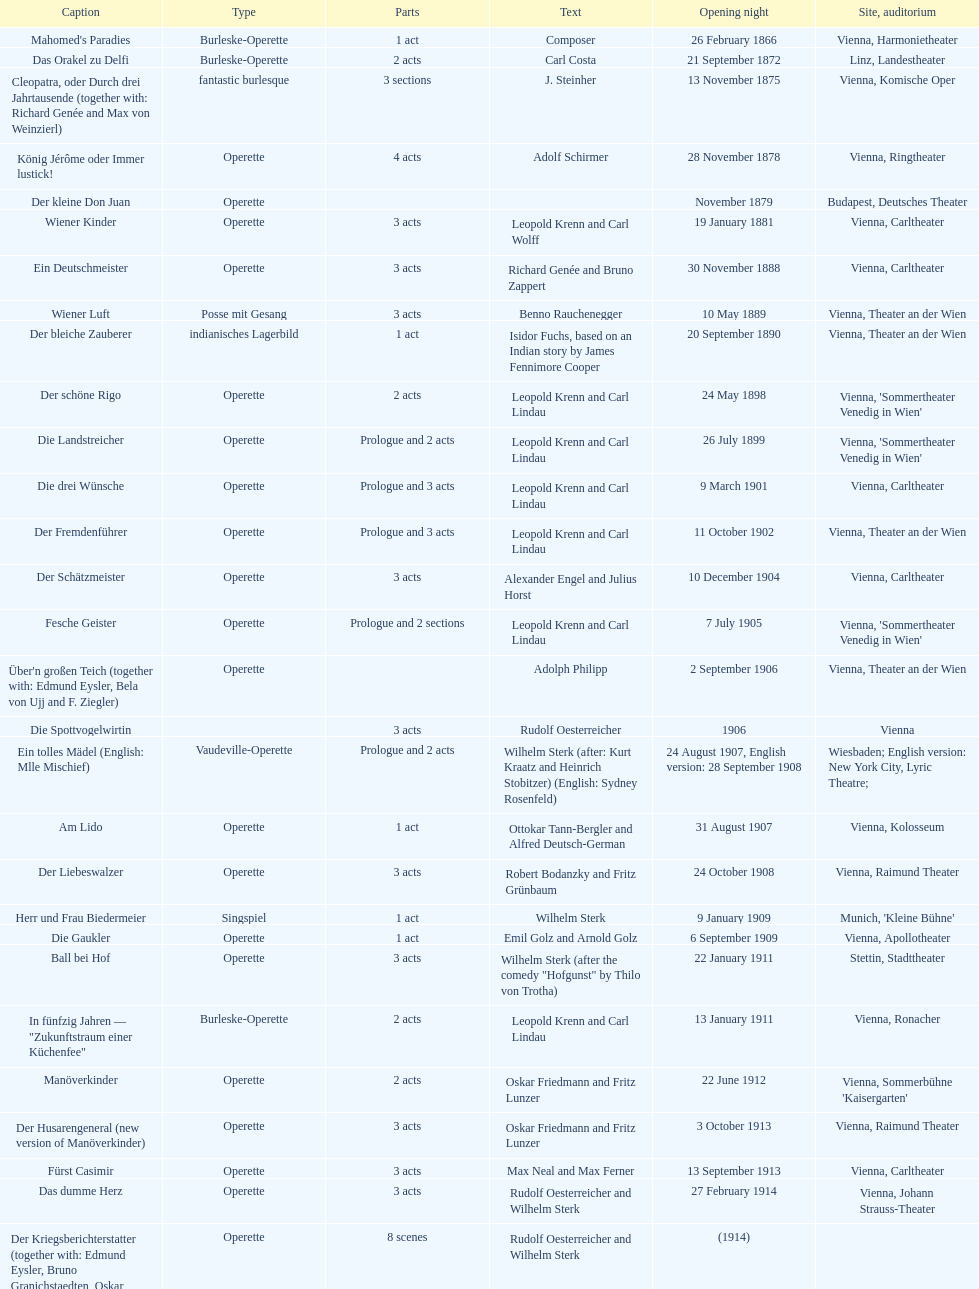What are the number of titles that premiered in the month of september? 4. 